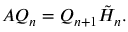<formula> <loc_0><loc_0><loc_500><loc_500>A Q _ { n } = Q _ { n + 1 } { \tilde { H } } _ { n } .</formula> 